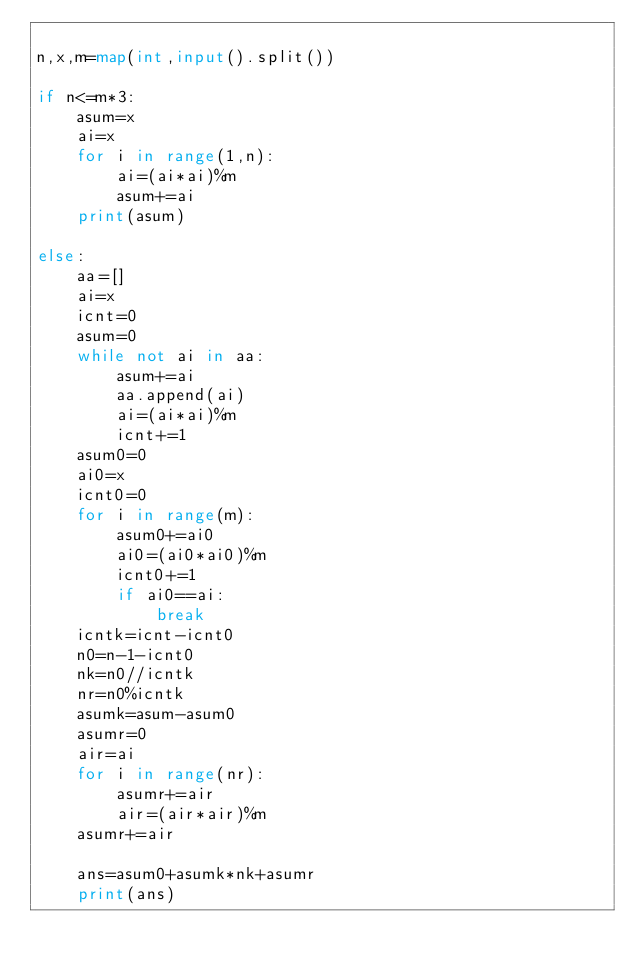Convert code to text. <code><loc_0><loc_0><loc_500><loc_500><_Python_>
n,x,m=map(int,input().split())

if n<=m*3:
    asum=x
    ai=x
    for i in range(1,n):
        ai=(ai*ai)%m
        asum+=ai
    print(asum)
    
else:
    aa=[]
    ai=x
    icnt=0
    asum=0
    while not ai in aa:
        asum+=ai
        aa.append(ai)
        ai=(ai*ai)%m
        icnt+=1
    asum0=0
    ai0=x
    icnt0=0
    for i in range(m):
        asum0+=ai0
        ai0=(ai0*ai0)%m
        icnt0+=1
        if ai0==ai:
            break
    icntk=icnt-icnt0
    n0=n-1-icnt0
    nk=n0//icntk
    nr=n0%icntk
    asumk=asum-asum0
    asumr=0
    air=ai
    for i in range(nr):
        asumr+=air
        air=(air*air)%m
    asumr+=air
       
    ans=asum0+asumk*nk+asumr    
    print(ans)       
        
</code> 